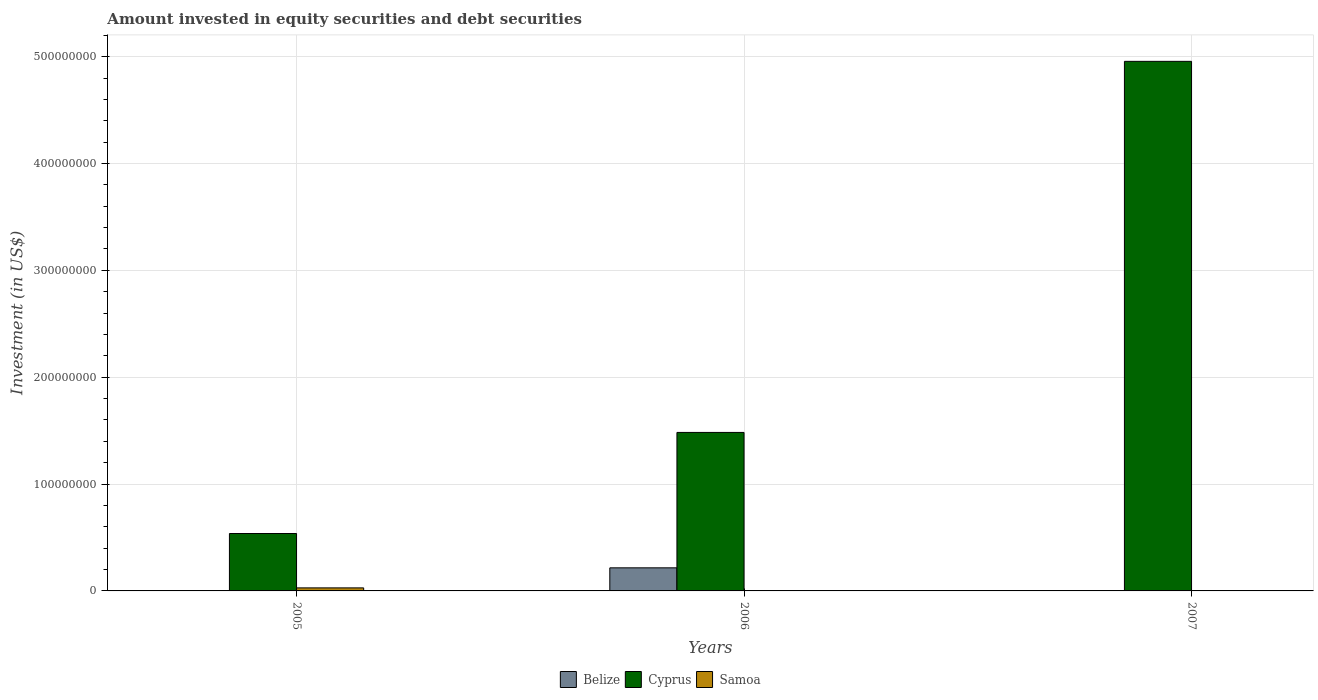Are the number of bars on each tick of the X-axis equal?
Give a very brief answer. No. What is the label of the 2nd group of bars from the left?
Offer a very short reply. 2006. What is the amount invested in equity securities and debt securities in Samoa in 2005?
Provide a short and direct response. 2.85e+06. Across all years, what is the maximum amount invested in equity securities and debt securities in Cyprus?
Offer a very short reply. 4.96e+08. Across all years, what is the minimum amount invested in equity securities and debt securities in Belize?
Your answer should be very brief. 0. What is the total amount invested in equity securities and debt securities in Cyprus in the graph?
Provide a succinct answer. 6.98e+08. What is the difference between the amount invested in equity securities and debt securities in Samoa in 2006 and that in 2007?
Make the answer very short. 2.15e+05. What is the difference between the amount invested in equity securities and debt securities in Cyprus in 2007 and the amount invested in equity securities and debt securities in Samoa in 2006?
Make the answer very short. 4.95e+08. What is the average amount invested in equity securities and debt securities in Cyprus per year?
Make the answer very short. 2.33e+08. In the year 2006, what is the difference between the amount invested in equity securities and debt securities in Cyprus and amount invested in equity securities and debt securities in Samoa?
Your response must be concise. 1.48e+08. What is the ratio of the amount invested in equity securities and debt securities in Samoa in 2006 to that in 2007?
Provide a short and direct response. 2.55. What is the difference between the highest and the second highest amount invested in equity securities and debt securities in Samoa?
Offer a terse response. 2.49e+06. What is the difference between the highest and the lowest amount invested in equity securities and debt securities in Cyprus?
Give a very brief answer. 4.42e+08. In how many years, is the amount invested in equity securities and debt securities in Samoa greater than the average amount invested in equity securities and debt securities in Samoa taken over all years?
Your response must be concise. 1. Are all the bars in the graph horizontal?
Your answer should be very brief. No. Does the graph contain any zero values?
Your answer should be very brief. Yes. Does the graph contain grids?
Your answer should be very brief. Yes. Where does the legend appear in the graph?
Provide a short and direct response. Bottom center. How many legend labels are there?
Provide a succinct answer. 3. How are the legend labels stacked?
Ensure brevity in your answer.  Horizontal. What is the title of the graph?
Provide a succinct answer. Amount invested in equity securities and debt securities. What is the label or title of the X-axis?
Provide a short and direct response. Years. What is the label or title of the Y-axis?
Ensure brevity in your answer.  Investment (in US$). What is the Investment (in US$) of Belize in 2005?
Make the answer very short. 0. What is the Investment (in US$) of Cyprus in 2005?
Give a very brief answer. 5.37e+07. What is the Investment (in US$) of Samoa in 2005?
Give a very brief answer. 2.85e+06. What is the Investment (in US$) in Belize in 2006?
Your answer should be very brief. 2.16e+07. What is the Investment (in US$) of Cyprus in 2006?
Ensure brevity in your answer.  1.48e+08. What is the Investment (in US$) in Samoa in 2006?
Ensure brevity in your answer.  3.53e+05. What is the Investment (in US$) of Cyprus in 2007?
Make the answer very short. 4.96e+08. What is the Investment (in US$) in Samoa in 2007?
Your response must be concise. 1.38e+05. Across all years, what is the maximum Investment (in US$) in Belize?
Keep it short and to the point. 2.16e+07. Across all years, what is the maximum Investment (in US$) of Cyprus?
Give a very brief answer. 4.96e+08. Across all years, what is the maximum Investment (in US$) in Samoa?
Your response must be concise. 2.85e+06. Across all years, what is the minimum Investment (in US$) in Belize?
Offer a very short reply. 0. Across all years, what is the minimum Investment (in US$) in Cyprus?
Ensure brevity in your answer.  5.37e+07. Across all years, what is the minimum Investment (in US$) in Samoa?
Give a very brief answer. 1.38e+05. What is the total Investment (in US$) in Belize in the graph?
Make the answer very short. 2.16e+07. What is the total Investment (in US$) of Cyprus in the graph?
Your answer should be compact. 6.98e+08. What is the total Investment (in US$) in Samoa in the graph?
Ensure brevity in your answer.  3.34e+06. What is the difference between the Investment (in US$) in Cyprus in 2005 and that in 2006?
Provide a short and direct response. -9.46e+07. What is the difference between the Investment (in US$) in Samoa in 2005 and that in 2006?
Make the answer very short. 2.49e+06. What is the difference between the Investment (in US$) of Cyprus in 2005 and that in 2007?
Provide a short and direct response. -4.42e+08. What is the difference between the Investment (in US$) of Samoa in 2005 and that in 2007?
Make the answer very short. 2.71e+06. What is the difference between the Investment (in US$) of Cyprus in 2006 and that in 2007?
Offer a terse response. -3.47e+08. What is the difference between the Investment (in US$) of Samoa in 2006 and that in 2007?
Your response must be concise. 2.15e+05. What is the difference between the Investment (in US$) in Cyprus in 2005 and the Investment (in US$) in Samoa in 2006?
Your response must be concise. 5.34e+07. What is the difference between the Investment (in US$) in Cyprus in 2005 and the Investment (in US$) in Samoa in 2007?
Offer a very short reply. 5.36e+07. What is the difference between the Investment (in US$) of Belize in 2006 and the Investment (in US$) of Cyprus in 2007?
Make the answer very short. -4.74e+08. What is the difference between the Investment (in US$) in Belize in 2006 and the Investment (in US$) in Samoa in 2007?
Provide a succinct answer. 2.15e+07. What is the difference between the Investment (in US$) of Cyprus in 2006 and the Investment (in US$) of Samoa in 2007?
Your answer should be very brief. 1.48e+08. What is the average Investment (in US$) of Belize per year?
Provide a short and direct response. 7.20e+06. What is the average Investment (in US$) of Cyprus per year?
Provide a short and direct response. 2.33e+08. What is the average Investment (in US$) in Samoa per year?
Provide a succinct answer. 1.11e+06. In the year 2005, what is the difference between the Investment (in US$) of Cyprus and Investment (in US$) of Samoa?
Your response must be concise. 5.09e+07. In the year 2006, what is the difference between the Investment (in US$) in Belize and Investment (in US$) in Cyprus?
Make the answer very short. -1.27e+08. In the year 2006, what is the difference between the Investment (in US$) of Belize and Investment (in US$) of Samoa?
Offer a very short reply. 2.13e+07. In the year 2006, what is the difference between the Investment (in US$) in Cyprus and Investment (in US$) in Samoa?
Your response must be concise. 1.48e+08. In the year 2007, what is the difference between the Investment (in US$) of Cyprus and Investment (in US$) of Samoa?
Your response must be concise. 4.95e+08. What is the ratio of the Investment (in US$) of Cyprus in 2005 to that in 2006?
Give a very brief answer. 0.36. What is the ratio of the Investment (in US$) of Samoa in 2005 to that in 2006?
Provide a short and direct response. 8.07. What is the ratio of the Investment (in US$) of Cyprus in 2005 to that in 2007?
Give a very brief answer. 0.11. What is the ratio of the Investment (in US$) in Samoa in 2005 to that in 2007?
Provide a short and direct response. 20.6. What is the ratio of the Investment (in US$) in Cyprus in 2006 to that in 2007?
Make the answer very short. 0.3. What is the ratio of the Investment (in US$) in Samoa in 2006 to that in 2007?
Your response must be concise. 2.55. What is the difference between the highest and the second highest Investment (in US$) of Cyprus?
Make the answer very short. 3.47e+08. What is the difference between the highest and the second highest Investment (in US$) in Samoa?
Ensure brevity in your answer.  2.49e+06. What is the difference between the highest and the lowest Investment (in US$) in Belize?
Give a very brief answer. 2.16e+07. What is the difference between the highest and the lowest Investment (in US$) of Cyprus?
Offer a very short reply. 4.42e+08. What is the difference between the highest and the lowest Investment (in US$) of Samoa?
Offer a very short reply. 2.71e+06. 